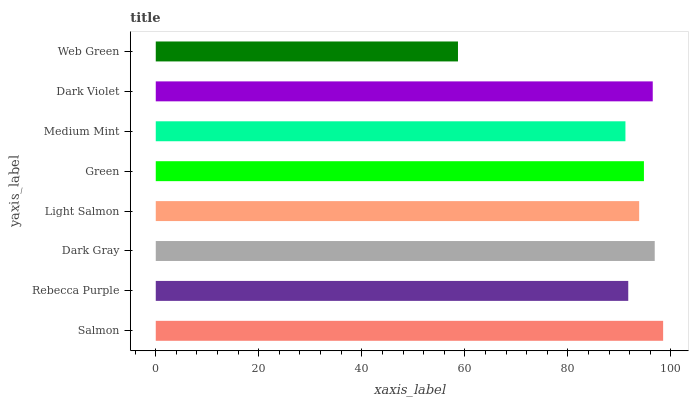Is Web Green the minimum?
Answer yes or no. Yes. Is Salmon the maximum?
Answer yes or no. Yes. Is Rebecca Purple the minimum?
Answer yes or no. No. Is Rebecca Purple the maximum?
Answer yes or no. No. Is Salmon greater than Rebecca Purple?
Answer yes or no. Yes. Is Rebecca Purple less than Salmon?
Answer yes or no. Yes. Is Rebecca Purple greater than Salmon?
Answer yes or no. No. Is Salmon less than Rebecca Purple?
Answer yes or no. No. Is Green the high median?
Answer yes or no. Yes. Is Light Salmon the low median?
Answer yes or no. Yes. Is Medium Mint the high median?
Answer yes or no. No. Is Dark Gray the low median?
Answer yes or no. No. 